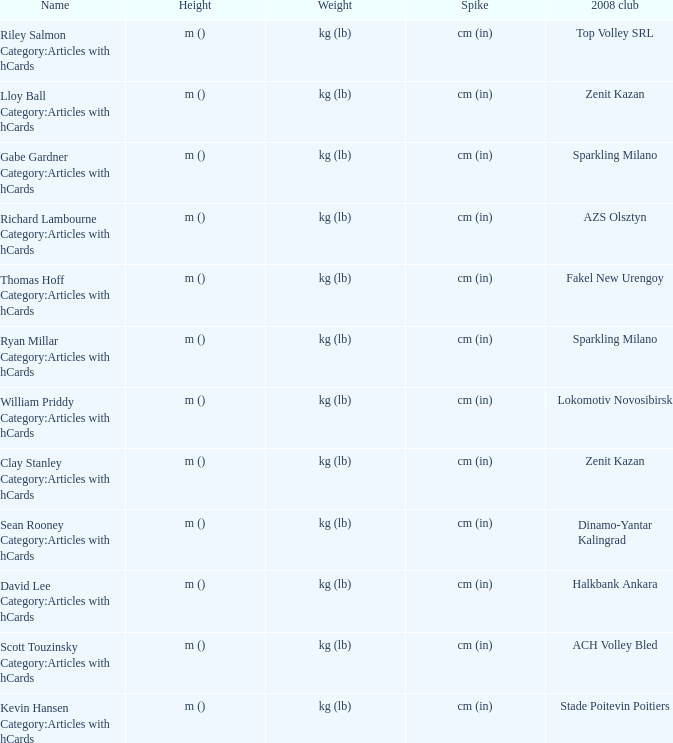What is the name for the 2008 club of Azs olsztyn? Richard Lambourne Category:Articles with hCards. 